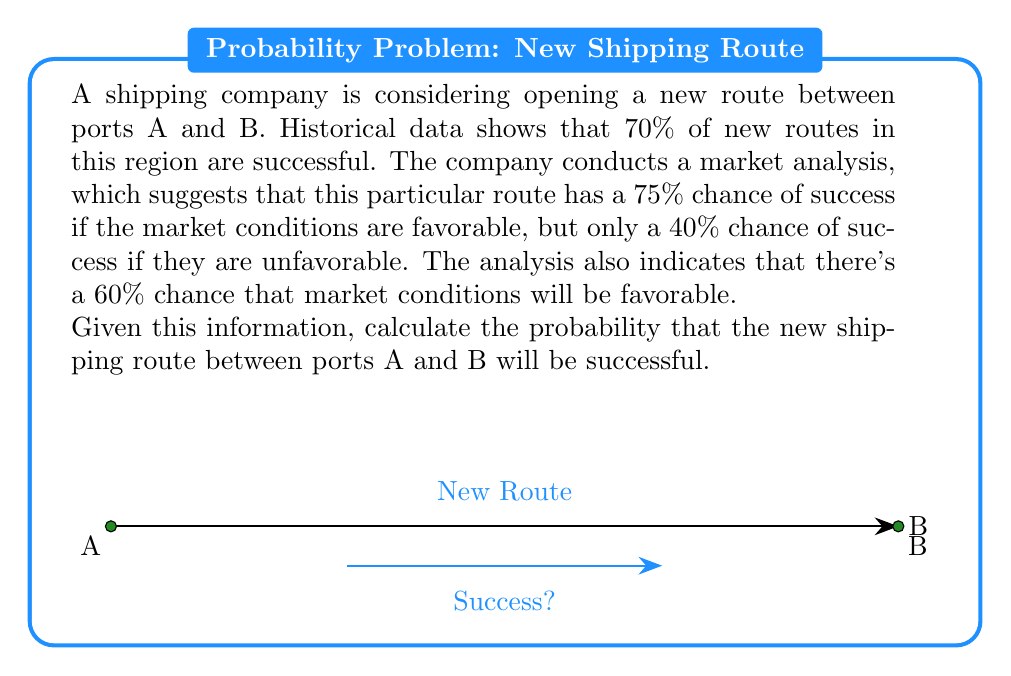Give your solution to this math problem. Let's approach this problem using Bayes' theorem and the law of total probability.

1) Define our events:
   S: The new route is successful
   F: Market conditions are favorable

2) Given probabilities:
   P(S|F) = 0.75 (probability of success given favorable conditions)
   P(S|not F) = 0.40 (probability of success given unfavorable conditions)
   P(F) = 0.60 (probability of favorable conditions)
   P(not F) = 1 - P(F) = 0.40 (probability of unfavorable conditions)

3) Use the law of total probability:
   $$P(S) = P(S|F) \cdot P(F) + P(S|not F) \cdot P(not F)$$

4) Substitute the values:
   $$P(S) = 0.75 \cdot 0.60 + 0.40 \cdot 0.40$$

5) Calculate:
   $$P(S) = 0.45 + 0.16 = 0.61$$

Therefore, the probability that the new shipping route will be successful is 0.61 or 61%.

6) Verify with prior probability:
   The historical success rate of 70% serves as a prior probability. Our calculated probability of 61% is lower, which makes sense given the specific market analysis for this route.
Answer: 0.61 